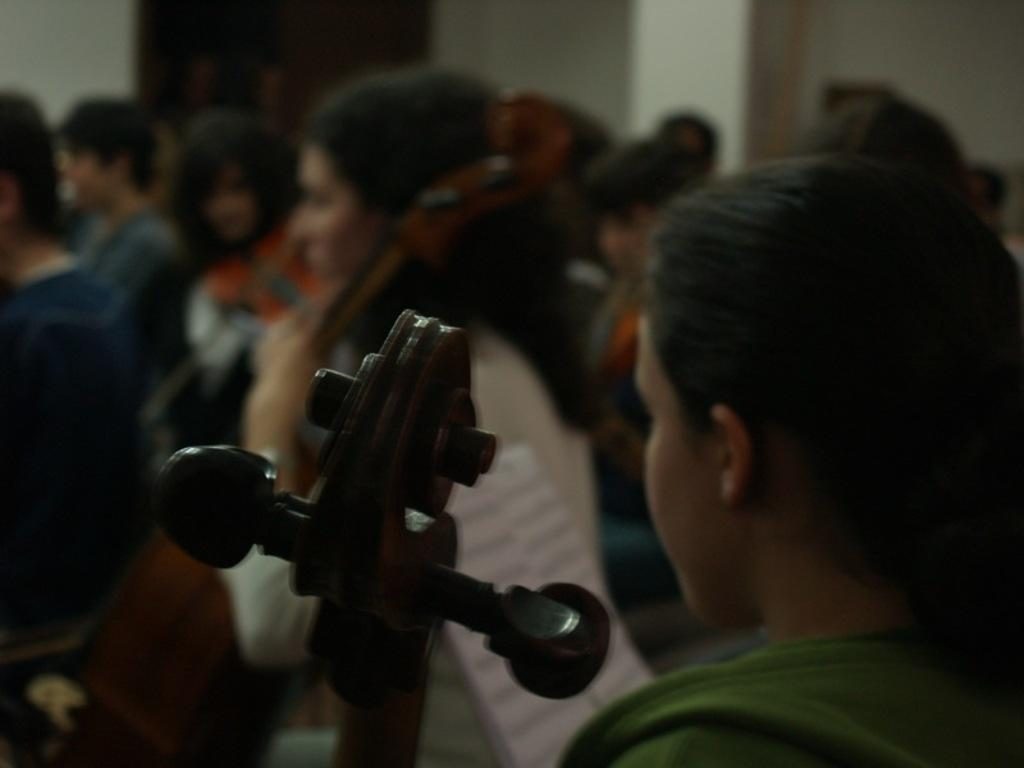What is the woman in the image holding? The woman is holding a music instrument. Can you describe the groups of people in the image? There are groups of people in the image, but their specific characteristics are not clear due to the provided facts. What is the background element in the image? There is a wall in the image. Are there any unclear or indistinct elements in the image? Yes, there are blurred items in the image. What type of horse can be seen on the plate in the image? There is no horse or plate present in the image. 